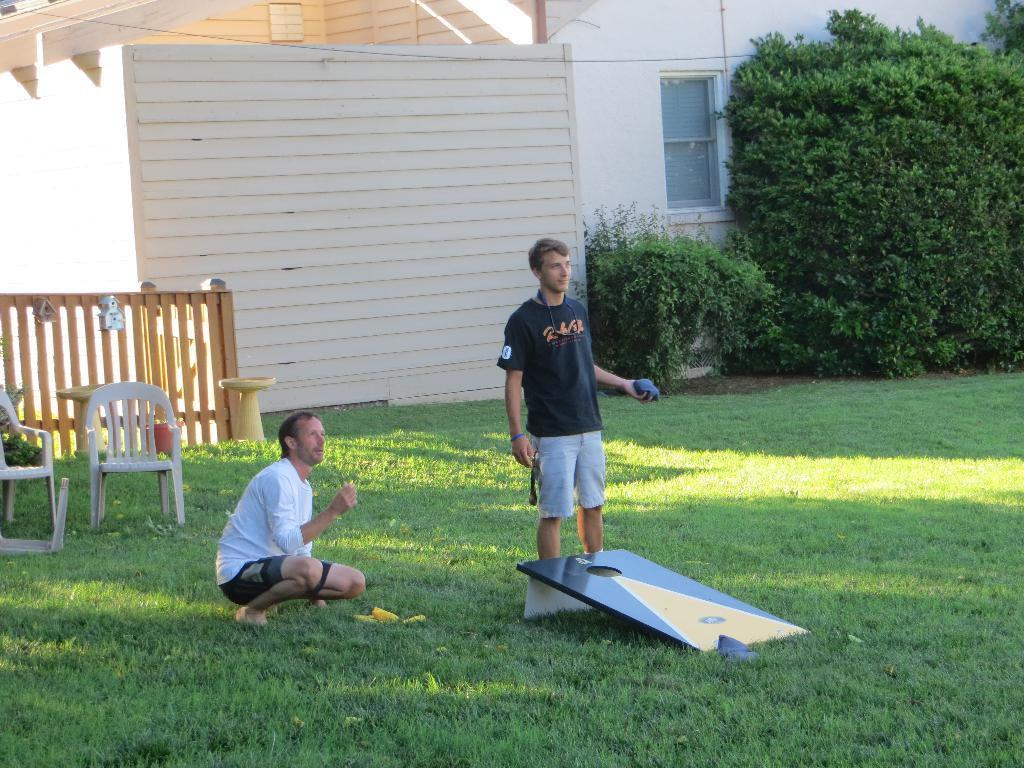How many people are in the image? There are two persons in the image. What is one person doing in the image? One person is standing and holding an object. What type of natural environment is visible in the image? There is grass in the image. What type of structure is present in the image? There is a building in the image. What type of barrier is present in the image? There is a wooden fence in the image. What type of living organisms can be seen in the image? There are plants in the image. Can you describe any other objects in the image? There are some other objects in the image, but their specific details are not mentioned in the provided facts. What type of stove can be seen in the image? There is no stove present in the image. How many ducks are visible in the image? There are no ducks visible in the image. 